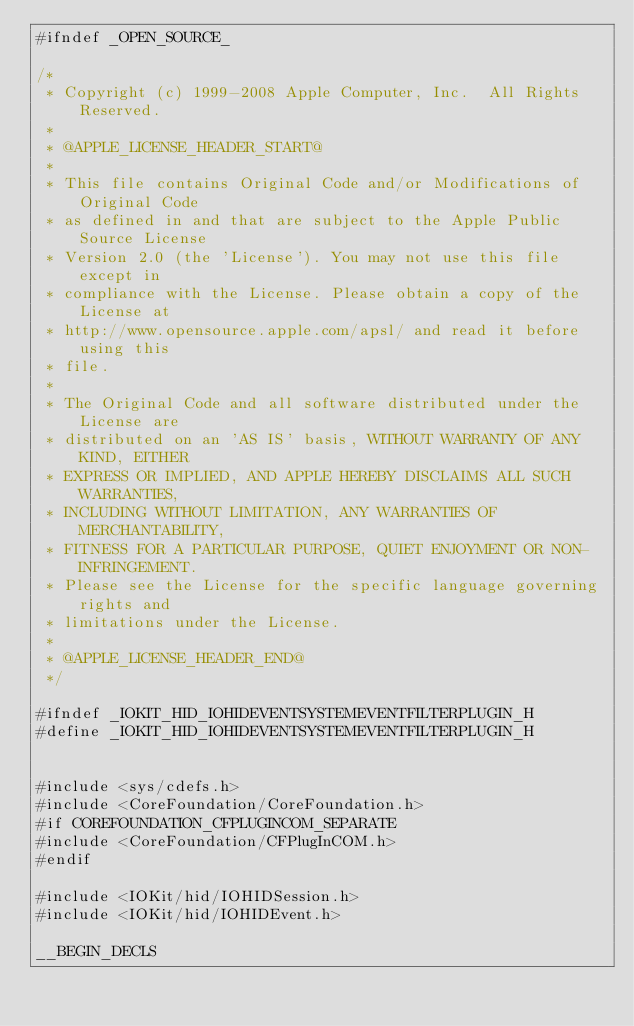Convert code to text. <code><loc_0><loc_0><loc_500><loc_500><_C_>#ifndef _OPEN_SOURCE_

/*
 * Copyright (c) 1999-2008 Apple Computer, Inc.  All Rights Reserved.
 * 
 * @APPLE_LICENSE_HEADER_START@
 * 
 * This file contains Original Code and/or Modifications of Original Code
 * as defined in and that are subject to the Apple Public Source License
 * Version 2.0 (the 'License'). You may not use this file except in
 * compliance with the License. Please obtain a copy of the License at
 * http://www.opensource.apple.com/apsl/ and read it before using this
 * file.
 * 
 * The Original Code and all software distributed under the License are
 * distributed on an 'AS IS' basis, WITHOUT WARRANTY OF ANY KIND, EITHER
 * EXPRESS OR IMPLIED, AND APPLE HEREBY DISCLAIMS ALL SUCH WARRANTIES,
 * INCLUDING WITHOUT LIMITATION, ANY WARRANTIES OF MERCHANTABILITY,
 * FITNESS FOR A PARTICULAR PURPOSE, QUIET ENJOYMENT OR NON-INFRINGEMENT.
 * Please see the License for the specific language governing rights and
 * limitations under the License.
 * 
 * @APPLE_LICENSE_HEADER_END@
 */

#ifndef _IOKIT_HID_IOHIDEVENTSYSTEMEVENTFILTERPLUGIN_H
#define _IOKIT_HID_IOHIDEVENTSYSTEMEVENTFILTERPLUGIN_H


#include <sys/cdefs.h>
#include <CoreFoundation/CoreFoundation.h>
#if COREFOUNDATION_CFPLUGINCOM_SEPARATE
#include <CoreFoundation/CFPlugInCOM.h>
#endif

#include <IOKit/hid/IOHIDSession.h>
#include <IOKit/hid/IOHIDEvent.h>

__BEGIN_DECLS

</code> 